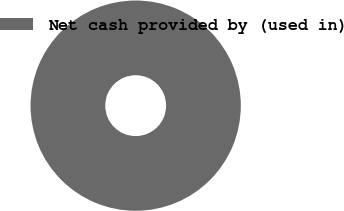<chart> <loc_0><loc_0><loc_500><loc_500><pie_chart><fcel>Net cash provided by (used in)<nl><fcel>100.0%<nl></chart> 